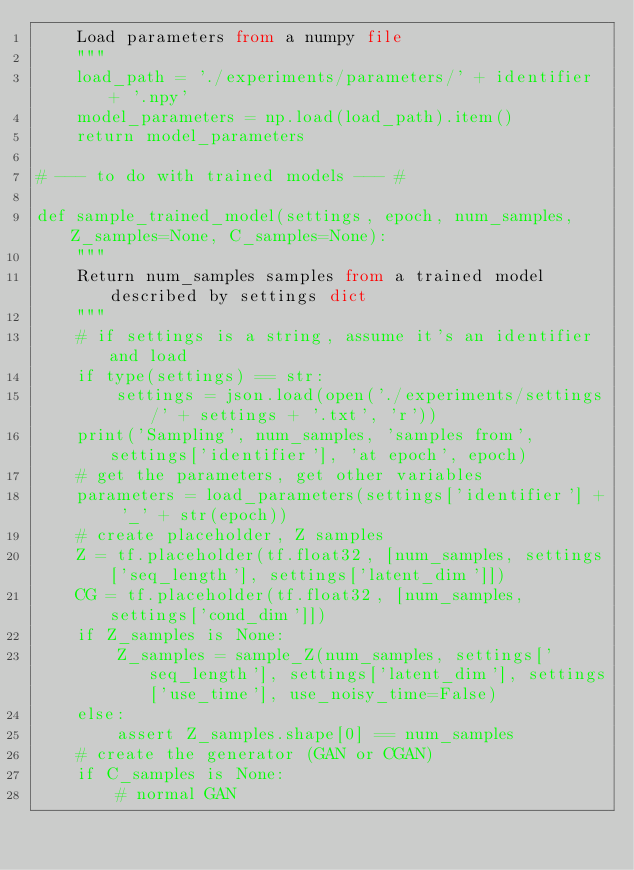Convert code to text. <code><loc_0><loc_0><loc_500><loc_500><_Python_>    Load parameters from a numpy file
    """
    load_path = './experiments/parameters/' + identifier + '.npy'
    model_parameters = np.load(load_path).item()
    return model_parameters

# --- to do with trained models --- #

def sample_trained_model(settings, epoch, num_samples, Z_samples=None, C_samples=None):
    """
    Return num_samples samples from a trained model described by settings dict
    """
    # if settings is a string, assume it's an identifier and load
    if type(settings) == str:
        settings = json.load(open('./experiments/settings/' + settings + '.txt', 'r'))
    print('Sampling', num_samples, 'samples from', settings['identifier'], 'at epoch', epoch)
    # get the parameters, get other variables
    parameters = load_parameters(settings['identifier'] + '_' + str(epoch))
    # create placeholder, Z samples
    Z = tf.placeholder(tf.float32, [num_samples, settings['seq_length'], settings['latent_dim']])
    CG = tf.placeholder(tf.float32, [num_samples, settings['cond_dim']])
    if Z_samples is None:
        Z_samples = sample_Z(num_samples, settings['seq_length'], settings['latent_dim'], settings['use_time'], use_noisy_time=False)
    else:
        assert Z_samples.shape[0] == num_samples
    # create the generator (GAN or CGAN)
    if C_samples is None:
        # normal GAN</code> 